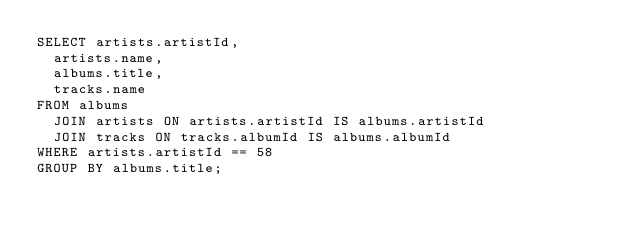<code> <loc_0><loc_0><loc_500><loc_500><_SQL_>SELECT artists.artistId,
  artists.name,
  albums.title,
  tracks.name
FROM albums
  JOIN artists ON artists.artistId IS albums.artistId
  JOIN tracks ON tracks.albumId IS albums.albumId
WHERE artists.artistId == 58
GROUP BY albums.title;</code> 